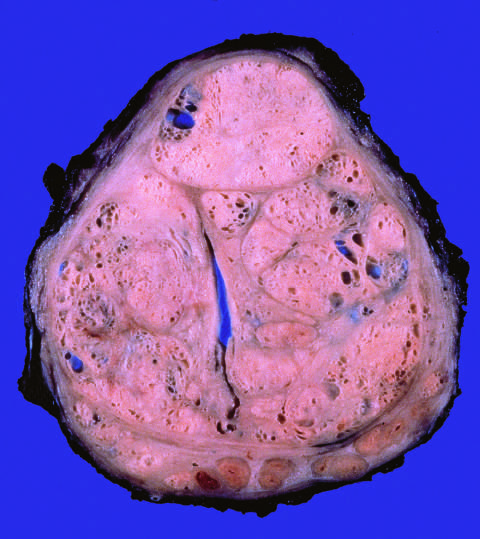what compress the urethra into a slitlike lumen?
Answer the question using a single word or phrase. Well-defined nodules 